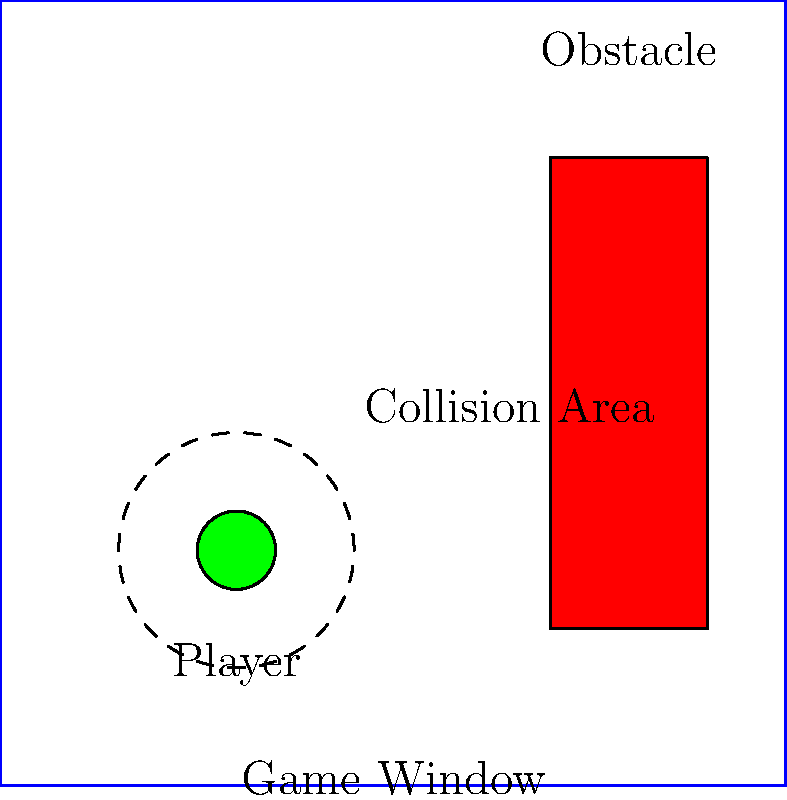In the context of implementing a simple 2D game engine in Rust, explain how you would approach collision detection between a circular player sprite and a rectangular obstacle, as shown in the diagram. What data structures and algorithms would you use to efficiently handle this scenario? To implement collision detection between a circular player sprite and a rectangular obstacle in a 2D game engine using Rust, we can follow these steps:

1. Define data structures:
   - Create a `struct` for the player with position (x, y) and radius.
   - Create a `struct` for the obstacle with position (x, y), width, and height.

2. Implement collision detection algorithm:
   - Use the Separating Axis Theorem (SAT) for circle-rectangle collision.
   - Calculate the closest point on the rectangle to the circle's center.
   - Check if the distance between this point and the circle's center is less than the circle's radius.

3. Optimize performance:
   - Use Rust's `Option<T>` to handle potential collisions efficiently.
   - Implement spatial partitioning (e.g., quadtree) to reduce the number of collision checks.

4. Handle collision response:
   - Calculate the collision normal and penetration depth.
   - Use the impulse resolution method to update velocities of colliding objects.

5. Integrate with game loop:
   - Update object positions based on their velocities.
   - Perform collision detection and resolution in each frame.

6. Utilize Rust's features:
   - Use traits to define common behavior for game objects.
   - Leverage Rust's ownership system to ensure memory safety and prevent data races.

7. Implement rendering:
   - Use a graphics library like `ggez` or `piston` to render sprites and shapes.
   - Update the visual representation based on collision results.

By following these steps and utilizing Rust's performance and safety features, you can create an efficient collision detection system for your 2D game engine.
Answer: Implement SAT algorithm for circle-rectangle collision, use spatial partitioning for optimization, and integrate with game loop using Rust's ownership system and traits. 